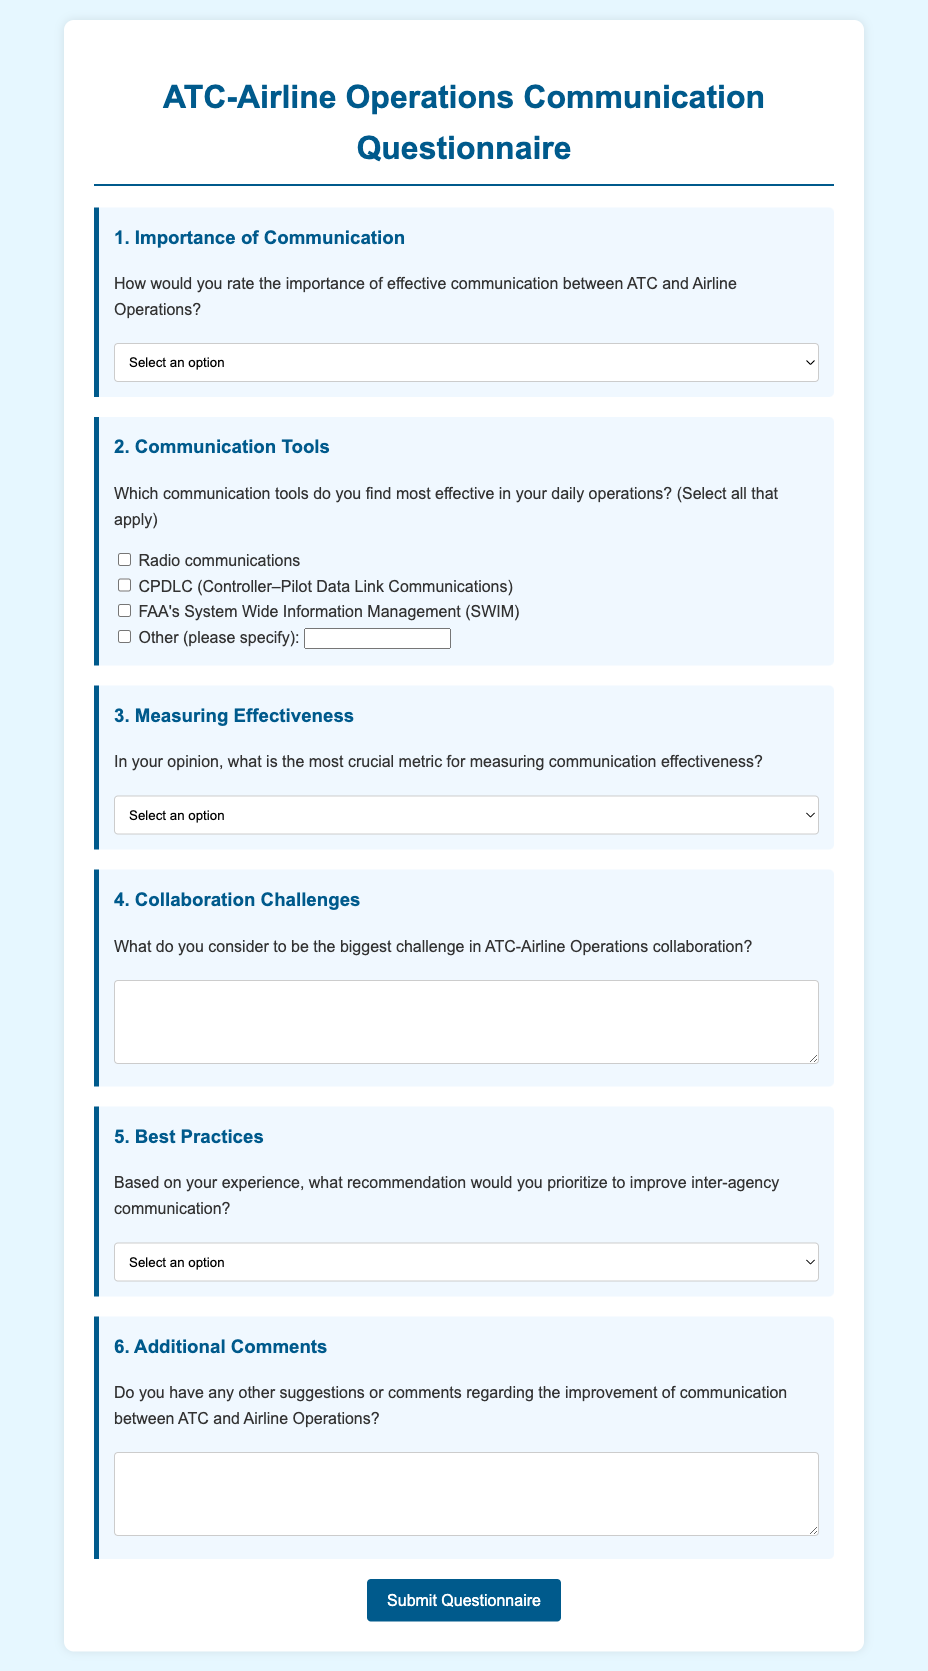What is the title of the questionnaire? The title of the questionnaire appears at the top of the document.
Answer: ATC-Airline Operations Communication Questionnaire What is the first question in the questionnaire? The first question is listed in the document under section one.
Answer: Importance of Communication How many options are provided for rating the importance of communication? The document specifies several options in a dropdown for rating importance.
Answer: Five Which communication tool is specifically mentioned as CPDLC? The tool mentioned in the document that is essentially an acronym stands for Controller–Pilot Data Link Communications.
Answer: CPDLC What is identified as a potential challenge in collaboration according to question four? The document contains a question aimed at identifying the challenges, but requests a written response.
Answer: (Open-ended response) What recommendation is given as the third option for improving inter-agency communication? The document provides several options for recommendations, and this is one among them.
Answer: Ensuring access to real-time data for both parties How is the questionnaire submitted? The document illustrates how the questionnaire can be transmitted for review.
Answer: Submit Questionnaire 